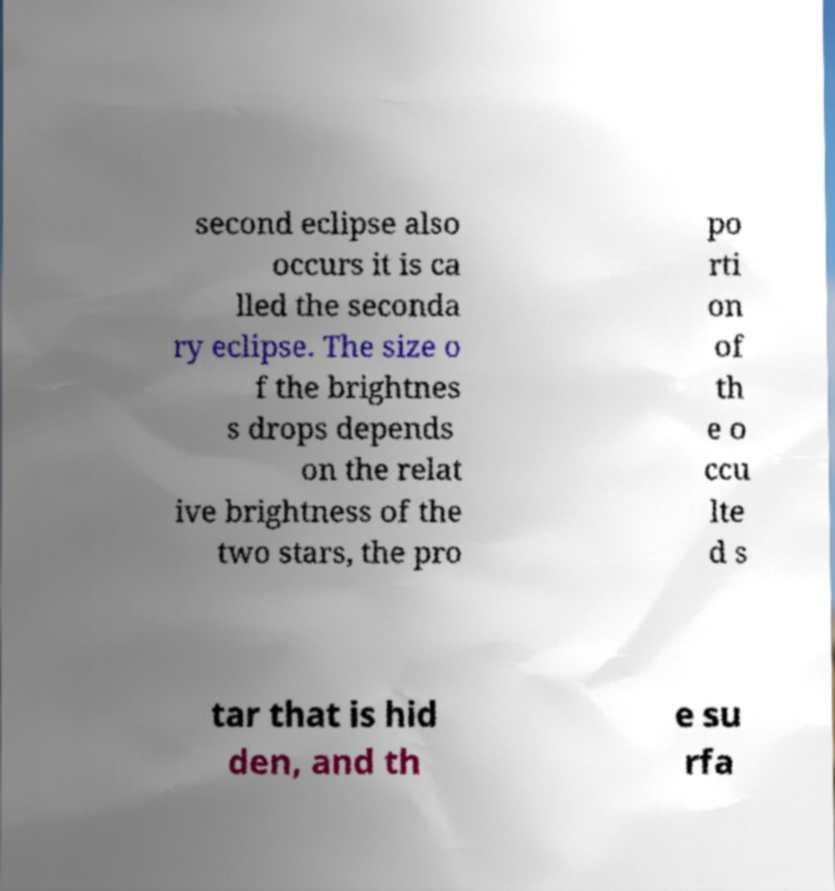Could you assist in decoding the text presented in this image and type it out clearly? second eclipse also occurs it is ca lled the seconda ry eclipse. The size o f the brightnes s drops depends on the relat ive brightness of the two stars, the pro po rti on of th e o ccu lte d s tar that is hid den, and th e su rfa 